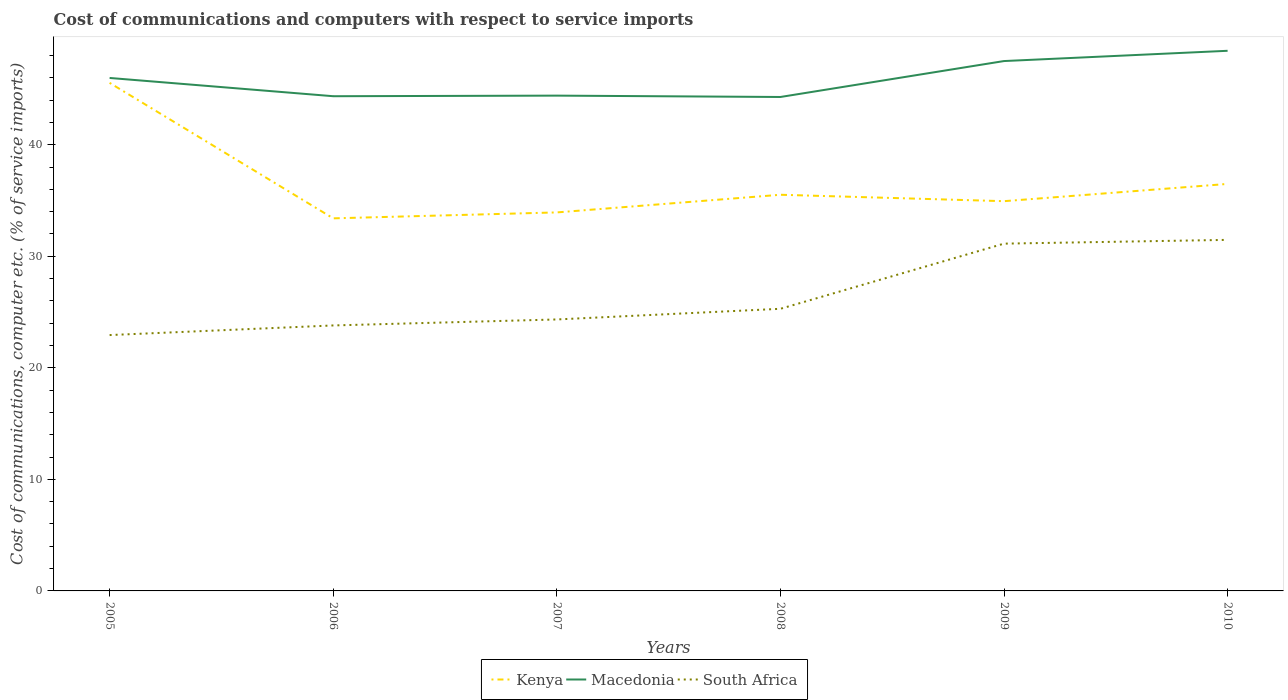Does the line corresponding to South Africa intersect with the line corresponding to Macedonia?
Offer a terse response. No. Across all years, what is the maximum cost of communications and computers in Macedonia?
Offer a very short reply. 44.28. In which year was the cost of communications and computers in Kenya maximum?
Offer a very short reply. 2006. What is the total cost of communications and computers in Kenya in the graph?
Provide a short and direct response. -3.09. What is the difference between the highest and the second highest cost of communications and computers in Kenya?
Your response must be concise. 12.15. What is the difference between the highest and the lowest cost of communications and computers in South Africa?
Offer a very short reply. 2. How many lines are there?
Make the answer very short. 3. How many years are there in the graph?
Offer a terse response. 6. What is the difference between two consecutive major ticks on the Y-axis?
Offer a very short reply. 10. Does the graph contain grids?
Keep it short and to the point. No. How are the legend labels stacked?
Your answer should be compact. Horizontal. What is the title of the graph?
Your answer should be compact. Cost of communications and computers with respect to service imports. What is the label or title of the Y-axis?
Provide a succinct answer. Cost of communications, computer etc. (% of service imports). What is the Cost of communications, computer etc. (% of service imports) of Kenya in 2005?
Provide a short and direct response. 45.55. What is the Cost of communications, computer etc. (% of service imports) in Macedonia in 2005?
Offer a terse response. 45.99. What is the Cost of communications, computer etc. (% of service imports) in South Africa in 2005?
Your response must be concise. 22.94. What is the Cost of communications, computer etc. (% of service imports) in Kenya in 2006?
Give a very brief answer. 33.4. What is the Cost of communications, computer etc. (% of service imports) in Macedonia in 2006?
Make the answer very short. 44.35. What is the Cost of communications, computer etc. (% of service imports) in South Africa in 2006?
Ensure brevity in your answer.  23.8. What is the Cost of communications, computer etc. (% of service imports) in Kenya in 2007?
Your answer should be compact. 33.93. What is the Cost of communications, computer etc. (% of service imports) in Macedonia in 2007?
Offer a terse response. 44.41. What is the Cost of communications, computer etc. (% of service imports) in South Africa in 2007?
Your answer should be very brief. 24.34. What is the Cost of communications, computer etc. (% of service imports) of Kenya in 2008?
Your answer should be compact. 35.52. What is the Cost of communications, computer etc. (% of service imports) in Macedonia in 2008?
Offer a terse response. 44.28. What is the Cost of communications, computer etc. (% of service imports) of South Africa in 2008?
Keep it short and to the point. 25.29. What is the Cost of communications, computer etc. (% of service imports) of Kenya in 2009?
Your answer should be very brief. 34.94. What is the Cost of communications, computer etc. (% of service imports) of Macedonia in 2009?
Offer a very short reply. 47.51. What is the Cost of communications, computer etc. (% of service imports) of South Africa in 2009?
Offer a very short reply. 31.14. What is the Cost of communications, computer etc. (% of service imports) of Kenya in 2010?
Your answer should be very brief. 36.49. What is the Cost of communications, computer etc. (% of service imports) of Macedonia in 2010?
Offer a terse response. 48.43. What is the Cost of communications, computer etc. (% of service imports) in South Africa in 2010?
Keep it short and to the point. 31.47. Across all years, what is the maximum Cost of communications, computer etc. (% of service imports) of Kenya?
Provide a short and direct response. 45.55. Across all years, what is the maximum Cost of communications, computer etc. (% of service imports) of Macedonia?
Offer a terse response. 48.43. Across all years, what is the maximum Cost of communications, computer etc. (% of service imports) in South Africa?
Provide a short and direct response. 31.47. Across all years, what is the minimum Cost of communications, computer etc. (% of service imports) in Kenya?
Offer a terse response. 33.4. Across all years, what is the minimum Cost of communications, computer etc. (% of service imports) of Macedonia?
Your answer should be very brief. 44.28. Across all years, what is the minimum Cost of communications, computer etc. (% of service imports) of South Africa?
Offer a terse response. 22.94. What is the total Cost of communications, computer etc. (% of service imports) of Kenya in the graph?
Provide a succinct answer. 219.84. What is the total Cost of communications, computer etc. (% of service imports) in Macedonia in the graph?
Your answer should be compact. 274.96. What is the total Cost of communications, computer etc. (% of service imports) in South Africa in the graph?
Ensure brevity in your answer.  158.98. What is the difference between the Cost of communications, computer etc. (% of service imports) of Kenya in 2005 and that in 2006?
Provide a succinct answer. 12.15. What is the difference between the Cost of communications, computer etc. (% of service imports) in Macedonia in 2005 and that in 2006?
Give a very brief answer. 1.64. What is the difference between the Cost of communications, computer etc. (% of service imports) in South Africa in 2005 and that in 2006?
Provide a short and direct response. -0.86. What is the difference between the Cost of communications, computer etc. (% of service imports) in Kenya in 2005 and that in 2007?
Give a very brief answer. 11.62. What is the difference between the Cost of communications, computer etc. (% of service imports) of Macedonia in 2005 and that in 2007?
Offer a very short reply. 1.58. What is the difference between the Cost of communications, computer etc. (% of service imports) in South Africa in 2005 and that in 2007?
Ensure brevity in your answer.  -1.4. What is the difference between the Cost of communications, computer etc. (% of service imports) in Kenya in 2005 and that in 2008?
Keep it short and to the point. 10.03. What is the difference between the Cost of communications, computer etc. (% of service imports) in Macedonia in 2005 and that in 2008?
Your answer should be very brief. 1.71. What is the difference between the Cost of communications, computer etc. (% of service imports) in South Africa in 2005 and that in 2008?
Your response must be concise. -2.36. What is the difference between the Cost of communications, computer etc. (% of service imports) in Kenya in 2005 and that in 2009?
Your answer should be compact. 10.61. What is the difference between the Cost of communications, computer etc. (% of service imports) in Macedonia in 2005 and that in 2009?
Your answer should be very brief. -1.51. What is the difference between the Cost of communications, computer etc. (% of service imports) in South Africa in 2005 and that in 2009?
Give a very brief answer. -8.2. What is the difference between the Cost of communications, computer etc. (% of service imports) of Kenya in 2005 and that in 2010?
Your answer should be compact. 9.06. What is the difference between the Cost of communications, computer etc. (% of service imports) in Macedonia in 2005 and that in 2010?
Your response must be concise. -2.44. What is the difference between the Cost of communications, computer etc. (% of service imports) in South Africa in 2005 and that in 2010?
Provide a short and direct response. -8.53. What is the difference between the Cost of communications, computer etc. (% of service imports) in Kenya in 2006 and that in 2007?
Your response must be concise. -0.53. What is the difference between the Cost of communications, computer etc. (% of service imports) in Macedonia in 2006 and that in 2007?
Your answer should be very brief. -0.05. What is the difference between the Cost of communications, computer etc. (% of service imports) of South Africa in 2006 and that in 2007?
Keep it short and to the point. -0.54. What is the difference between the Cost of communications, computer etc. (% of service imports) of Kenya in 2006 and that in 2008?
Give a very brief answer. -2.11. What is the difference between the Cost of communications, computer etc. (% of service imports) of Macedonia in 2006 and that in 2008?
Provide a short and direct response. 0.07. What is the difference between the Cost of communications, computer etc. (% of service imports) in South Africa in 2006 and that in 2008?
Offer a very short reply. -1.49. What is the difference between the Cost of communications, computer etc. (% of service imports) in Kenya in 2006 and that in 2009?
Keep it short and to the point. -1.54. What is the difference between the Cost of communications, computer etc. (% of service imports) of Macedonia in 2006 and that in 2009?
Give a very brief answer. -3.15. What is the difference between the Cost of communications, computer etc. (% of service imports) of South Africa in 2006 and that in 2009?
Give a very brief answer. -7.33. What is the difference between the Cost of communications, computer etc. (% of service imports) of Kenya in 2006 and that in 2010?
Keep it short and to the point. -3.09. What is the difference between the Cost of communications, computer etc. (% of service imports) of Macedonia in 2006 and that in 2010?
Provide a short and direct response. -4.07. What is the difference between the Cost of communications, computer etc. (% of service imports) of South Africa in 2006 and that in 2010?
Keep it short and to the point. -7.67. What is the difference between the Cost of communications, computer etc. (% of service imports) in Kenya in 2007 and that in 2008?
Your response must be concise. -1.58. What is the difference between the Cost of communications, computer etc. (% of service imports) of Macedonia in 2007 and that in 2008?
Offer a terse response. 0.12. What is the difference between the Cost of communications, computer etc. (% of service imports) in South Africa in 2007 and that in 2008?
Keep it short and to the point. -0.96. What is the difference between the Cost of communications, computer etc. (% of service imports) of Kenya in 2007 and that in 2009?
Offer a very short reply. -1.01. What is the difference between the Cost of communications, computer etc. (% of service imports) of Macedonia in 2007 and that in 2009?
Offer a terse response. -3.1. What is the difference between the Cost of communications, computer etc. (% of service imports) in South Africa in 2007 and that in 2009?
Your answer should be very brief. -6.8. What is the difference between the Cost of communications, computer etc. (% of service imports) in Kenya in 2007 and that in 2010?
Provide a short and direct response. -2.56. What is the difference between the Cost of communications, computer etc. (% of service imports) of Macedonia in 2007 and that in 2010?
Your answer should be very brief. -4.02. What is the difference between the Cost of communications, computer etc. (% of service imports) of South Africa in 2007 and that in 2010?
Offer a very short reply. -7.13. What is the difference between the Cost of communications, computer etc. (% of service imports) in Kenya in 2008 and that in 2009?
Offer a very short reply. 0.57. What is the difference between the Cost of communications, computer etc. (% of service imports) of Macedonia in 2008 and that in 2009?
Your answer should be very brief. -3.22. What is the difference between the Cost of communications, computer etc. (% of service imports) of South Africa in 2008 and that in 2009?
Your response must be concise. -5.84. What is the difference between the Cost of communications, computer etc. (% of service imports) in Kenya in 2008 and that in 2010?
Your answer should be compact. -0.97. What is the difference between the Cost of communications, computer etc. (% of service imports) of Macedonia in 2008 and that in 2010?
Make the answer very short. -4.14. What is the difference between the Cost of communications, computer etc. (% of service imports) in South Africa in 2008 and that in 2010?
Your answer should be very brief. -6.18. What is the difference between the Cost of communications, computer etc. (% of service imports) of Kenya in 2009 and that in 2010?
Your answer should be compact. -1.55. What is the difference between the Cost of communications, computer etc. (% of service imports) in Macedonia in 2009 and that in 2010?
Give a very brief answer. -0.92. What is the difference between the Cost of communications, computer etc. (% of service imports) in South Africa in 2009 and that in 2010?
Ensure brevity in your answer.  -0.34. What is the difference between the Cost of communications, computer etc. (% of service imports) of Kenya in 2005 and the Cost of communications, computer etc. (% of service imports) of Macedonia in 2006?
Offer a very short reply. 1.2. What is the difference between the Cost of communications, computer etc. (% of service imports) in Kenya in 2005 and the Cost of communications, computer etc. (% of service imports) in South Africa in 2006?
Ensure brevity in your answer.  21.75. What is the difference between the Cost of communications, computer etc. (% of service imports) in Macedonia in 2005 and the Cost of communications, computer etc. (% of service imports) in South Africa in 2006?
Make the answer very short. 22.19. What is the difference between the Cost of communications, computer etc. (% of service imports) of Kenya in 2005 and the Cost of communications, computer etc. (% of service imports) of Macedonia in 2007?
Ensure brevity in your answer.  1.14. What is the difference between the Cost of communications, computer etc. (% of service imports) of Kenya in 2005 and the Cost of communications, computer etc. (% of service imports) of South Africa in 2007?
Your response must be concise. 21.21. What is the difference between the Cost of communications, computer etc. (% of service imports) in Macedonia in 2005 and the Cost of communications, computer etc. (% of service imports) in South Africa in 2007?
Make the answer very short. 21.65. What is the difference between the Cost of communications, computer etc. (% of service imports) in Kenya in 2005 and the Cost of communications, computer etc. (% of service imports) in Macedonia in 2008?
Make the answer very short. 1.27. What is the difference between the Cost of communications, computer etc. (% of service imports) in Kenya in 2005 and the Cost of communications, computer etc. (% of service imports) in South Africa in 2008?
Provide a succinct answer. 20.26. What is the difference between the Cost of communications, computer etc. (% of service imports) in Macedonia in 2005 and the Cost of communications, computer etc. (% of service imports) in South Africa in 2008?
Provide a short and direct response. 20.7. What is the difference between the Cost of communications, computer etc. (% of service imports) in Kenya in 2005 and the Cost of communications, computer etc. (% of service imports) in Macedonia in 2009?
Offer a terse response. -1.95. What is the difference between the Cost of communications, computer etc. (% of service imports) of Kenya in 2005 and the Cost of communications, computer etc. (% of service imports) of South Africa in 2009?
Keep it short and to the point. 14.42. What is the difference between the Cost of communications, computer etc. (% of service imports) of Macedonia in 2005 and the Cost of communications, computer etc. (% of service imports) of South Africa in 2009?
Your response must be concise. 14.85. What is the difference between the Cost of communications, computer etc. (% of service imports) in Kenya in 2005 and the Cost of communications, computer etc. (% of service imports) in Macedonia in 2010?
Provide a short and direct response. -2.87. What is the difference between the Cost of communications, computer etc. (% of service imports) of Kenya in 2005 and the Cost of communications, computer etc. (% of service imports) of South Africa in 2010?
Make the answer very short. 14.08. What is the difference between the Cost of communications, computer etc. (% of service imports) in Macedonia in 2005 and the Cost of communications, computer etc. (% of service imports) in South Africa in 2010?
Your answer should be very brief. 14.52. What is the difference between the Cost of communications, computer etc. (% of service imports) in Kenya in 2006 and the Cost of communications, computer etc. (% of service imports) in Macedonia in 2007?
Your answer should be very brief. -11. What is the difference between the Cost of communications, computer etc. (% of service imports) of Kenya in 2006 and the Cost of communications, computer etc. (% of service imports) of South Africa in 2007?
Keep it short and to the point. 9.07. What is the difference between the Cost of communications, computer etc. (% of service imports) of Macedonia in 2006 and the Cost of communications, computer etc. (% of service imports) of South Africa in 2007?
Keep it short and to the point. 20.01. What is the difference between the Cost of communications, computer etc. (% of service imports) of Kenya in 2006 and the Cost of communications, computer etc. (% of service imports) of Macedonia in 2008?
Your response must be concise. -10.88. What is the difference between the Cost of communications, computer etc. (% of service imports) in Kenya in 2006 and the Cost of communications, computer etc. (% of service imports) in South Africa in 2008?
Ensure brevity in your answer.  8.11. What is the difference between the Cost of communications, computer etc. (% of service imports) of Macedonia in 2006 and the Cost of communications, computer etc. (% of service imports) of South Africa in 2008?
Ensure brevity in your answer.  19.06. What is the difference between the Cost of communications, computer etc. (% of service imports) in Kenya in 2006 and the Cost of communications, computer etc. (% of service imports) in Macedonia in 2009?
Provide a short and direct response. -14.1. What is the difference between the Cost of communications, computer etc. (% of service imports) in Kenya in 2006 and the Cost of communications, computer etc. (% of service imports) in South Africa in 2009?
Keep it short and to the point. 2.27. What is the difference between the Cost of communications, computer etc. (% of service imports) of Macedonia in 2006 and the Cost of communications, computer etc. (% of service imports) of South Africa in 2009?
Make the answer very short. 13.22. What is the difference between the Cost of communications, computer etc. (% of service imports) in Kenya in 2006 and the Cost of communications, computer etc. (% of service imports) in Macedonia in 2010?
Make the answer very short. -15.02. What is the difference between the Cost of communications, computer etc. (% of service imports) of Kenya in 2006 and the Cost of communications, computer etc. (% of service imports) of South Africa in 2010?
Your response must be concise. 1.93. What is the difference between the Cost of communications, computer etc. (% of service imports) in Macedonia in 2006 and the Cost of communications, computer etc. (% of service imports) in South Africa in 2010?
Offer a terse response. 12.88. What is the difference between the Cost of communications, computer etc. (% of service imports) of Kenya in 2007 and the Cost of communications, computer etc. (% of service imports) of Macedonia in 2008?
Keep it short and to the point. -10.35. What is the difference between the Cost of communications, computer etc. (% of service imports) of Kenya in 2007 and the Cost of communications, computer etc. (% of service imports) of South Africa in 2008?
Keep it short and to the point. 8.64. What is the difference between the Cost of communications, computer etc. (% of service imports) in Macedonia in 2007 and the Cost of communications, computer etc. (% of service imports) in South Africa in 2008?
Provide a short and direct response. 19.11. What is the difference between the Cost of communications, computer etc. (% of service imports) of Kenya in 2007 and the Cost of communications, computer etc. (% of service imports) of Macedonia in 2009?
Your answer should be compact. -13.57. What is the difference between the Cost of communications, computer etc. (% of service imports) in Kenya in 2007 and the Cost of communications, computer etc. (% of service imports) in South Africa in 2009?
Your answer should be very brief. 2.8. What is the difference between the Cost of communications, computer etc. (% of service imports) in Macedonia in 2007 and the Cost of communications, computer etc. (% of service imports) in South Africa in 2009?
Your response must be concise. 13.27. What is the difference between the Cost of communications, computer etc. (% of service imports) of Kenya in 2007 and the Cost of communications, computer etc. (% of service imports) of Macedonia in 2010?
Keep it short and to the point. -14.49. What is the difference between the Cost of communications, computer etc. (% of service imports) of Kenya in 2007 and the Cost of communications, computer etc. (% of service imports) of South Africa in 2010?
Keep it short and to the point. 2.46. What is the difference between the Cost of communications, computer etc. (% of service imports) of Macedonia in 2007 and the Cost of communications, computer etc. (% of service imports) of South Africa in 2010?
Provide a short and direct response. 12.93. What is the difference between the Cost of communications, computer etc. (% of service imports) of Kenya in 2008 and the Cost of communications, computer etc. (% of service imports) of Macedonia in 2009?
Provide a short and direct response. -11.99. What is the difference between the Cost of communications, computer etc. (% of service imports) in Kenya in 2008 and the Cost of communications, computer etc. (% of service imports) in South Africa in 2009?
Your answer should be very brief. 4.38. What is the difference between the Cost of communications, computer etc. (% of service imports) in Macedonia in 2008 and the Cost of communications, computer etc. (% of service imports) in South Africa in 2009?
Your answer should be very brief. 13.15. What is the difference between the Cost of communications, computer etc. (% of service imports) in Kenya in 2008 and the Cost of communications, computer etc. (% of service imports) in Macedonia in 2010?
Ensure brevity in your answer.  -12.91. What is the difference between the Cost of communications, computer etc. (% of service imports) of Kenya in 2008 and the Cost of communications, computer etc. (% of service imports) of South Africa in 2010?
Offer a terse response. 4.04. What is the difference between the Cost of communications, computer etc. (% of service imports) in Macedonia in 2008 and the Cost of communications, computer etc. (% of service imports) in South Africa in 2010?
Your response must be concise. 12.81. What is the difference between the Cost of communications, computer etc. (% of service imports) in Kenya in 2009 and the Cost of communications, computer etc. (% of service imports) in Macedonia in 2010?
Keep it short and to the point. -13.48. What is the difference between the Cost of communications, computer etc. (% of service imports) of Kenya in 2009 and the Cost of communications, computer etc. (% of service imports) of South Africa in 2010?
Make the answer very short. 3.47. What is the difference between the Cost of communications, computer etc. (% of service imports) in Macedonia in 2009 and the Cost of communications, computer etc. (% of service imports) in South Africa in 2010?
Your response must be concise. 16.03. What is the average Cost of communications, computer etc. (% of service imports) of Kenya per year?
Make the answer very short. 36.64. What is the average Cost of communications, computer etc. (% of service imports) of Macedonia per year?
Give a very brief answer. 45.83. What is the average Cost of communications, computer etc. (% of service imports) of South Africa per year?
Your response must be concise. 26.5. In the year 2005, what is the difference between the Cost of communications, computer etc. (% of service imports) in Kenya and Cost of communications, computer etc. (% of service imports) in Macedonia?
Provide a short and direct response. -0.44. In the year 2005, what is the difference between the Cost of communications, computer etc. (% of service imports) of Kenya and Cost of communications, computer etc. (% of service imports) of South Africa?
Ensure brevity in your answer.  22.61. In the year 2005, what is the difference between the Cost of communications, computer etc. (% of service imports) of Macedonia and Cost of communications, computer etc. (% of service imports) of South Africa?
Your answer should be very brief. 23.05. In the year 2006, what is the difference between the Cost of communications, computer etc. (% of service imports) in Kenya and Cost of communications, computer etc. (% of service imports) in Macedonia?
Keep it short and to the point. -10.95. In the year 2006, what is the difference between the Cost of communications, computer etc. (% of service imports) in Kenya and Cost of communications, computer etc. (% of service imports) in South Africa?
Provide a succinct answer. 9.6. In the year 2006, what is the difference between the Cost of communications, computer etc. (% of service imports) in Macedonia and Cost of communications, computer etc. (% of service imports) in South Africa?
Offer a very short reply. 20.55. In the year 2007, what is the difference between the Cost of communications, computer etc. (% of service imports) in Kenya and Cost of communications, computer etc. (% of service imports) in Macedonia?
Give a very brief answer. -10.47. In the year 2007, what is the difference between the Cost of communications, computer etc. (% of service imports) of Kenya and Cost of communications, computer etc. (% of service imports) of South Africa?
Provide a short and direct response. 9.6. In the year 2007, what is the difference between the Cost of communications, computer etc. (% of service imports) of Macedonia and Cost of communications, computer etc. (% of service imports) of South Africa?
Offer a very short reply. 20.07. In the year 2008, what is the difference between the Cost of communications, computer etc. (% of service imports) in Kenya and Cost of communications, computer etc. (% of service imports) in Macedonia?
Provide a short and direct response. -8.77. In the year 2008, what is the difference between the Cost of communications, computer etc. (% of service imports) of Kenya and Cost of communications, computer etc. (% of service imports) of South Africa?
Make the answer very short. 10.22. In the year 2008, what is the difference between the Cost of communications, computer etc. (% of service imports) of Macedonia and Cost of communications, computer etc. (% of service imports) of South Africa?
Provide a succinct answer. 18.99. In the year 2009, what is the difference between the Cost of communications, computer etc. (% of service imports) in Kenya and Cost of communications, computer etc. (% of service imports) in Macedonia?
Your answer should be compact. -12.56. In the year 2009, what is the difference between the Cost of communications, computer etc. (% of service imports) in Kenya and Cost of communications, computer etc. (% of service imports) in South Africa?
Offer a terse response. 3.81. In the year 2009, what is the difference between the Cost of communications, computer etc. (% of service imports) of Macedonia and Cost of communications, computer etc. (% of service imports) of South Africa?
Ensure brevity in your answer.  16.37. In the year 2010, what is the difference between the Cost of communications, computer etc. (% of service imports) of Kenya and Cost of communications, computer etc. (% of service imports) of Macedonia?
Keep it short and to the point. -11.94. In the year 2010, what is the difference between the Cost of communications, computer etc. (% of service imports) in Kenya and Cost of communications, computer etc. (% of service imports) in South Africa?
Your answer should be compact. 5.02. In the year 2010, what is the difference between the Cost of communications, computer etc. (% of service imports) in Macedonia and Cost of communications, computer etc. (% of service imports) in South Africa?
Offer a very short reply. 16.95. What is the ratio of the Cost of communications, computer etc. (% of service imports) in Kenya in 2005 to that in 2006?
Offer a terse response. 1.36. What is the ratio of the Cost of communications, computer etc. (% of service imports) of Macedonia in 2005 to that in 2006?
Your answer should be very brief. 1.04. What is the ratio of the Cost of communications, computer etc. (% of service imports) of South Africa in 2005 to that in 2006?
Offer a very short reply. 0.96. What is the ratio of the Cost of communications, computer etc. (% of service imports) in Kenya in 2005 to that in 2007?
Keep it short and to the point. 1.34. What is the ratio of the Cost of communications, computer etc. (% of service imports) in Macedonia in 2005 to that in 2007?
Your response must be concise. 1.04. What is the ratio of the Cost of communications, computer etc. (% of service imports) of South Africa in 2005 to that in 2007?
Make the answer very short. 0.94. What is the ratio of the Cost of communications, computer etc. (% of service imports) of Kenya in 2005 to that in 2008?
Give a very brief answer. 1.28. What is the ratio of the Cost of communications, computer etc. (% of service imports) of Macedonia in 2005 to that in 2008?
Provide a short and direct response. 1.04. What is the ratio of the Cost of communications, computer etc. (% of service imports) of South Africa in 2005 to that in 2008?
Offer a terse response. 0.91. What is the ratio of the Cost of communications, computer etc. (% of service imports) of Kenya in 2005 to that in 2009?
Keep it short and to the point. 1.3. What is the ratio of the Cost of communications, computer etc. (% of service imports) of Macedonia in 2005 to that in 2009?
Offer a very short reply. 0.97. What is the ratio of the Cost of communications, computer etc. (% of service imports) of South Africa in 2005 to that in 2009?
Your answer should be compact. 0.74. What is the ratio of the Cost of communications, computer etc. (% of service imports) in Kenya in 2005 to that in 2010?
Make the answer very short. 1.25. What is the ratio of the Cost of communications, computer etc. (% of service imports) in Macedonia in 2005 to that in 2010?
Your response must be concise. 0.95. What is the ratio of the Cost of communications, computer etc. (% of service imports) in South Africa in 2005 to that in 2010?
Give a very brief answer. 0.73. What is the ratio of the Cost of communications, computer etc. (% of service imports) in Kenya in 2006 to that in 2007?
Your response must be concise. 0.98. What is the ratio of the Cost of communications, computer etc. (% of service imports) of Macedonia in 2006 to that in 2007?
Keep it short and to the point. 1. What is the ratio of the Cost of communications, computer etc. (% of service imports) of South Africa in 2006 to that in 2007?
Provide a short and direct response. 0.98. What is the ratio of the Cost of communications, computer etc. (% of service imports) of Kenya in 2006 to that in 2008?
Offer a terse response. 0.94. What is the ratio of the Cost of communications, computer etc. (% of service imports) of South Africa in 2006 to that in 2008?
Provide a short and direct response. 0.94. What is the ratio of the Cost of communications, computer etc. (% of service imports) of Kenya in 2006 to that in 2009?
Provide a succinct answer. 0.96. What is the ratio of the Cost of communications, computer etc. (% of service imports) of Macedonia in 2006 to that in 2009?
Keep it short and to the point. 0.93. What is the ratio of the Cost of communications, computer etc. (% of service imports) of South Africa in 2006 to that in 2009?
Provide a succinct answer. 0.76. What is the ratio of the Cost of communications, computer etc. (% of service imports) in Kenya in 2006 to that in 2010?
Offer a very short reply. 0.92. What is the ratio of the Cost of communications, computer etc. (% of service imports) of Macedonia in 2006 to that in 2010?
Your response must be concise. 0.92. What is the ratio of the Cost of communications, computer etc. (% of service imports) of South Africa in 2006 to that in 2010?
Your answer should be compact. 0.76. What is the ratio of the Cost of communications, computer etc. (% of service imports) of Kenya in 2007 to that in 2008?
Provide a succinct answer. 0.96. What is the ratio of the Cost of communications, computer etc. (% of service imports) in South Africa in 2007 to that in 2008?
Give a very brief answer. 0.96. What is the ratio of the Cost of communications, computer etc. (% of service imports) in Kenya in 2007 to that in 2009?
Offer a very short reply. 0.97. What is the ratio of the Cost of communications, computer etc. (% of service imports) in Macedonia in 2007 to that in 2009?
Offer a terse response. 0.93. What is the ratio of the Cost of communications, computer etc. (% of service imports) in South Africa in 2007 to that in 2009?
Your response must be concise. 0.78. What is the ratio of the Cost of communications, computer etc. (% of service imports) in Kenya in 2007 to that in 2010?
Your answer should be very brief. 0.93. What is the ratio of the Cost of communications, computer etc. (% of service imports) in Macedonia in 2007 to that in 2010?
Provide a short and direct response. 0.92. What is the ratio of the Cost of communications, computer etc. (% of service imports) of South Africa in 2007 to that in 2010?
Keep it short and to the point. 0.77. What is the ratio of the Cost of communications, computer etc. (% of service imports) in Kenya in 2008 to that in 2009?
Your response must be concise. 1.02. What is the ratio of the Cost of communications, computer etc. (% of service imports) in Macedonia in 2008 to that in 2009?
Offer a very short reply. 0.93. What is the ratio of the Cost of communications, computer etc. (% of service imports) in South Africa in 2008 to that in 2009?
Keep it short and to the point. 0.81. What is the ratio of the Cost of communications, computer etc. (% of service imports) in Kenya in 2008 to that in 2010?
Offer a very short reply. 0.97. What is the ratio of the Cost of communications, computer etc. (% of service imports) in Macedonia in 2008 to that in 2010?
Offer a very short reply. 0.91. What is the ratio of the Cost of communications, computer etc. (% of service imports) of South Africa in 2008 to that in 2010?
Offer a terse response. 0.8. What is the ratio of the Cost of communications, computer etc. (% of service imports) of Kenya in 2009 to that in 2010?
Your response must be concise. 0.96. What is the ratio of the Cost of communications, computer etc. (% of service imports) in Macedonia in 2009 to that in 2010?
Make the answer very short. 0.98. What is the ratio of the Cost of communications, computer etc. (% of service imports) in South Africa in 2009 to that in 2010?
Provide a short and direct response. 0.99. What is the difference between the highest and the second highest Cost of communications, computer etc. (% of service imports) in Kenya?
Ensure brevity in your answer.  9.06. What is the difference between the highest and the second highest Cost of communications, computer etc. (% of service imports) of Macedonia?
Offer a terse response. 0.92. What is the difference between the highest and the second highest Cost of communications, computer etc. (% of service imports) in South Africa?
Make the answer very short. 0.34. What is the difference between the highest and the lowest Cost of communications, computer etc. (% of service imports) of Kenya?
Provide a short and direct response. 12.15. What is the difference between the highest and the lowest Cost of communications, computer etc. (% of service imports) in Macedonia?
Your answer should be very brief. 4.14. What is the difference between the highest and the lowest Cost of communications, computer etc. (% of service imports) in South Africa?
Provide a succinct answer. 8.53. 